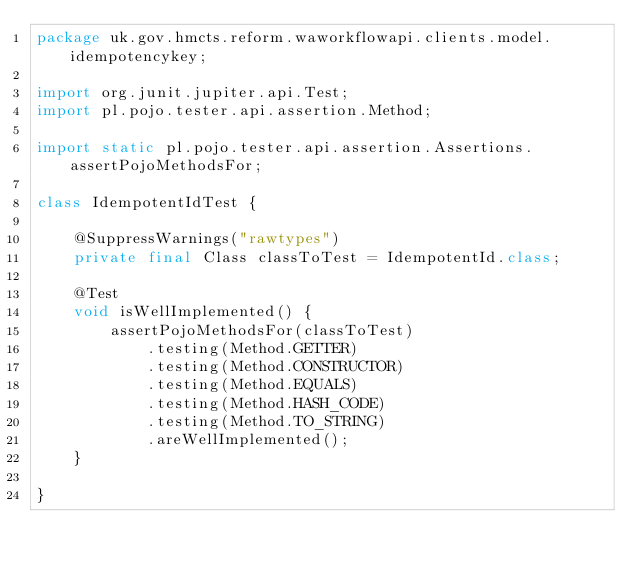<code> <loc_0><loc_0><loc_500><loc_500><_Java_>package uk.gov.hmcts.reform.waworkflowapi.clients.model.idempotencykey;

import org.junit.jupiter.api.Test;
import pl.pojo.tester.api.assertion.Method;

import static pl.pojo.tester.api.assertion.Assertions.assertPojoMethodsFor;

class IdempotentIdTest {

    @SuppressWarnings("rawtypes")
    private final Class classToTest = IdempotentId.class;

    @Test
    void isWellImplemented() {
        assertPojoMethodsFor(classToTest)
            .testing(Method.GETTER)
            .testing(Method.CONSTRUCTOR)
            .testing(Method.EQUALS)
            .testing(Method.HASH_CODE)
            .testing(Method.TO_STRING)
            .areWellImplemented();
    }

}
</code> 